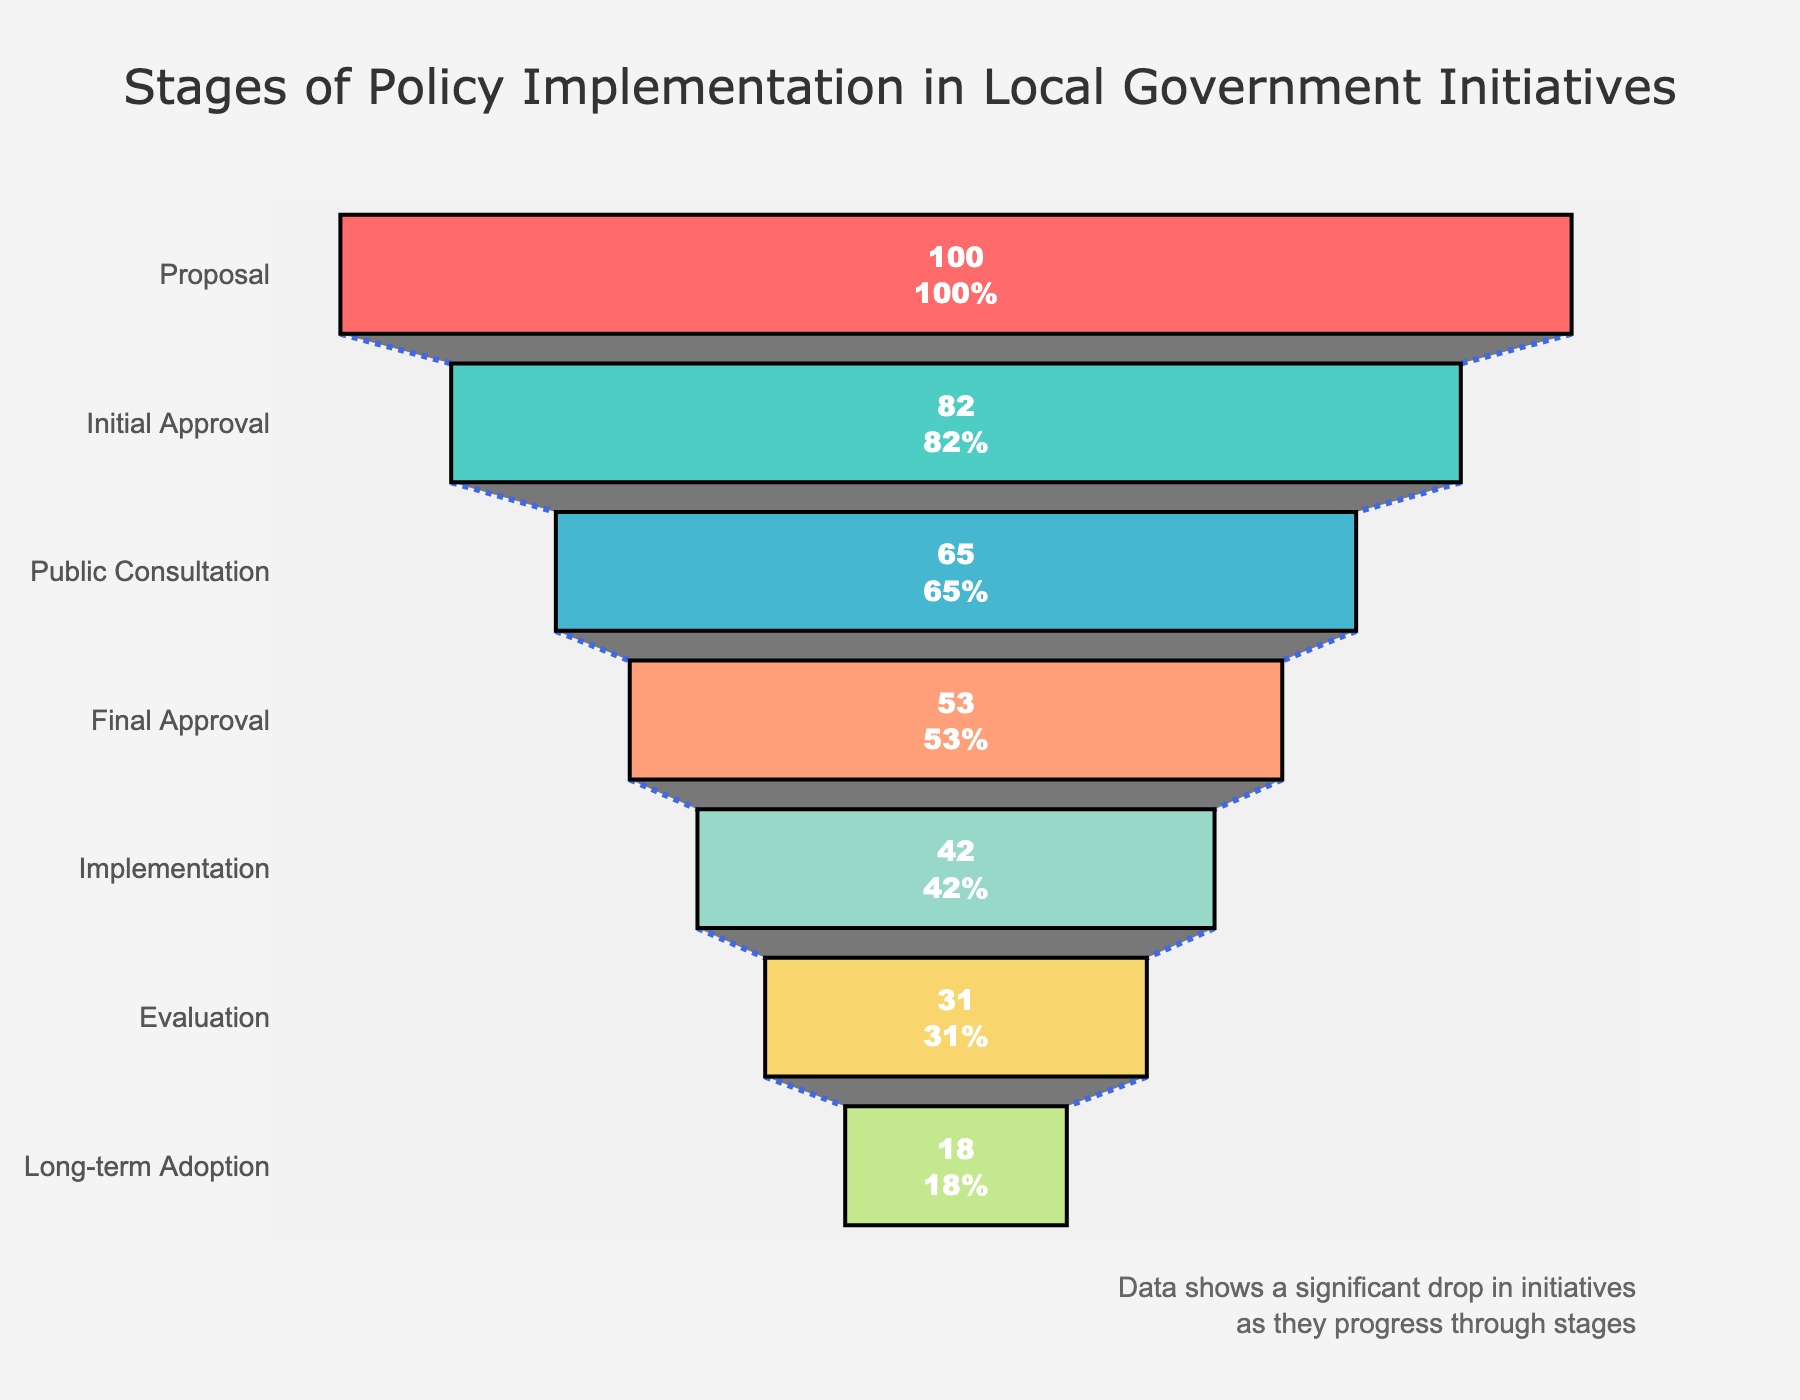What's the title of the plot? The title is located at the top of the plot, centered and highlighted in a larger font compared to other text elements. The exact wording of the title is: "Stages of Policy Implementation in Local Government Initiatives".
Answer: Stages of Policy Implementation in Local Government Initiatives How many stages are there in the process? By counting the distinct sections or segments of the funnel chart, we find there are seven stages from top to bottom. These stages are listed within each segment along with the respective number of initiatives.
Answer: Seven What percentage of initiatives make it through the Initial Approval stage? According to the text inside the funnel chart and the summary above each section, the percentage is displayed along with the number of initiatives. For Initial Approval, it shows both 82 initiatives and their respective percentage from the total of 100 proposals, which is 82%.
Answer: 82% By how many initiatives does the number decrease between Proposal and Implementation? Starting with 100 initiatives at Proposal and decreasing to 42 at Implementation, the drop is calculated by subtracting the lower number from the higher: 100 - 42 = 58.
Answer: 58 Which stage sees the greatest drop in the number of initiatives? To determine this, compare the differences in numbers between consecutive stages. Here are the differences: Proposal to Initial Approval (18), Initial Approval to Public Consultation (17), Public Consultation to Final Approval (12), Final Approval to Implementation (11), Implementation to Evaluation (11), Evaluation to Long-term Adoption (13). The largest drop is between Proposal and Initial Approval, which is 18 initiatives.
Answer: Proposal to Initial Approval How many initiatives successfully reach Long-term Adoption? The final stage in the funnel chart, labeled Long-term Adoption, explicitly states the number of initiatives that complete this stage as 18.
Answer: 18 What is the combined total of initiatives that do not make it past Public Consultation? Initiatives that fall off before Public Consultation are those from Proposal and Initial Approval but not reaching Public Consultation. This number is found by subtracting the number of initiatives at Public Consultation from the initial 100: 100 - 65 = 35.
Answer: 35 Which color represents the Public Consultation stage? Observing the funnel chart, each stage is uniquely colored. The Public Consultation stage is marked with a distinct light blue color, differentiating it from the others.
Answer: Light blue Is there any annotation provided in the chart? If yes, what does it say? Below the funnel chart, there is an annotation presented in a smaller font, right-aligned at the bottom. The annotation provides additional insight: "Data shows a significant drop in initiatives as they progress through stages".
Answer: Data shows a significant drop in initiatives as they progress through stages 